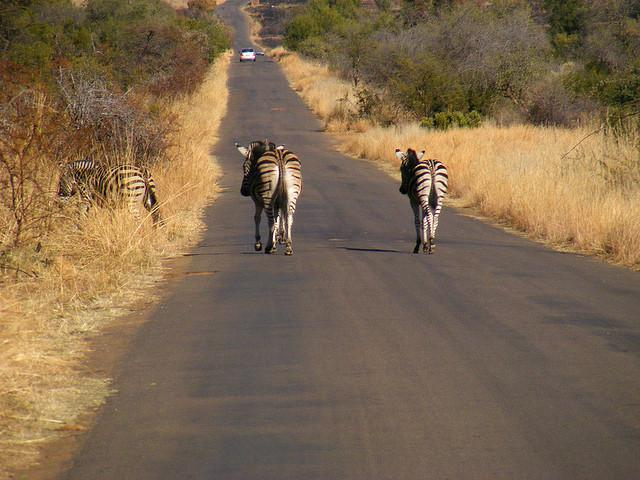What are the animals showing to the camera? zebra 